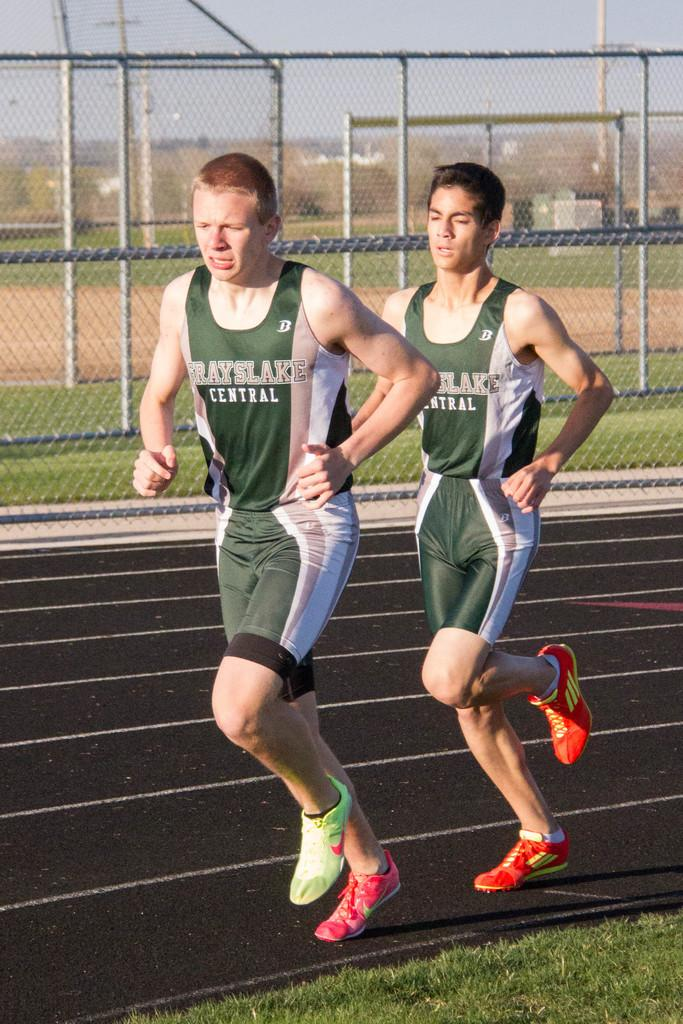<image>
Create a compact narrative representing the image presented. Two kids running a track with a Grayslake Central jersey 